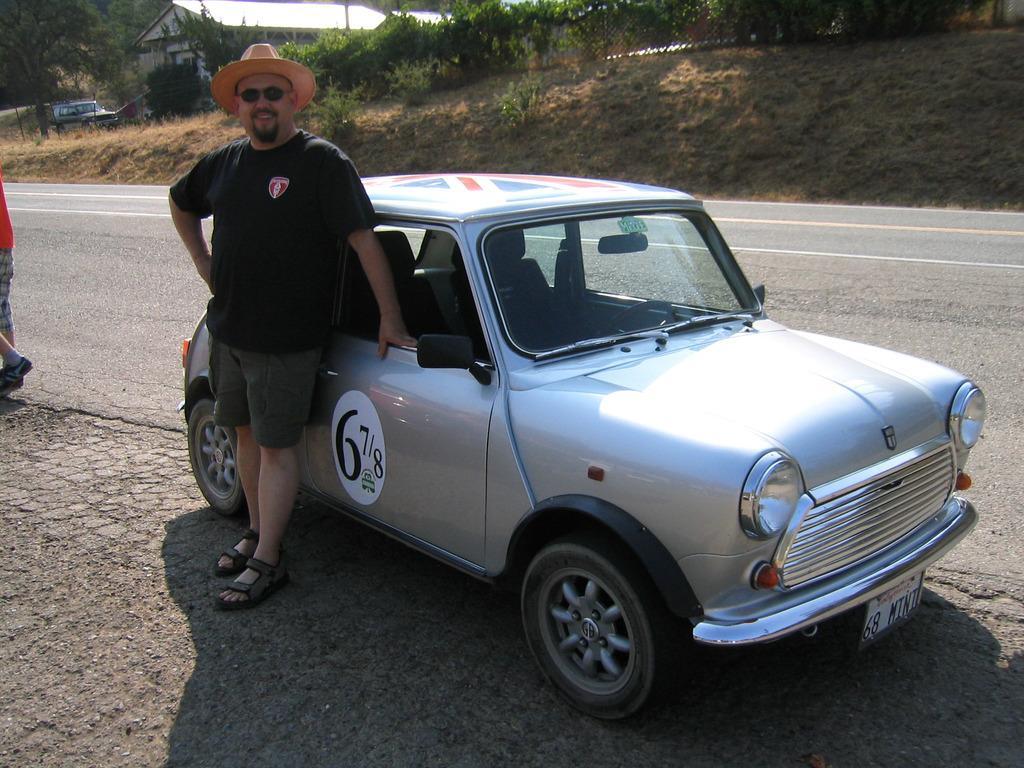Please provide a concise description of this image. In this image we can see few persons. A man is wearing a hat on his head. There are few vehicles in the image. There is a house in the image. There is a road in the image. There are many trees and plants in the image. 